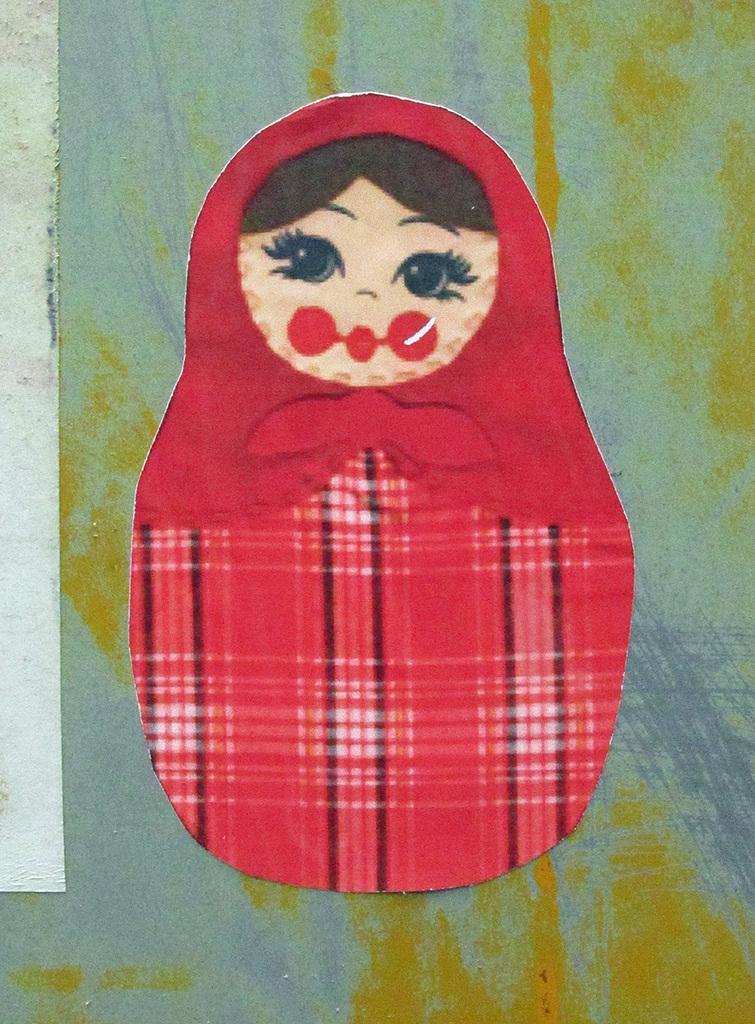How would you summarize this image in a sentence or two? In the picture we can see painting of a kid who is wearing red color dress. 